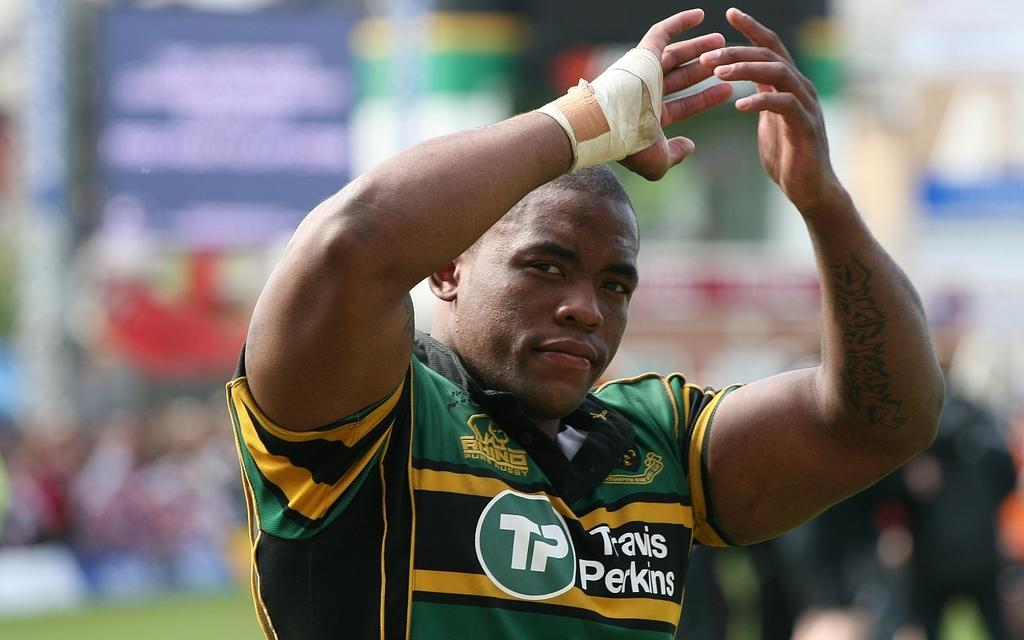<image>
Render a clear and concise summary of the photo. A muscular man claps his hands while wearing a Travis Perkins jersey. 